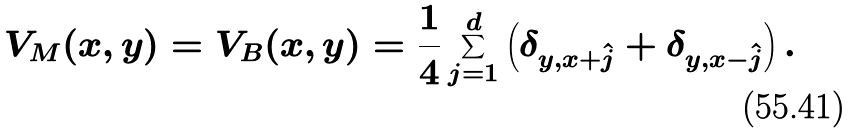Convert formula to latex. <formula><loc_0><loc_0><loc_500><loc_500>V _ { M } ( x , y ) = V _ { B } ( x , y ) = \frac { 1 } { 4 } \sum _ { j = 1 } ^ { d } \left ( \delta _ { y , x + \hat { j } } + \delta _ { y , x - \hat { j } } \right ) .</formula> 